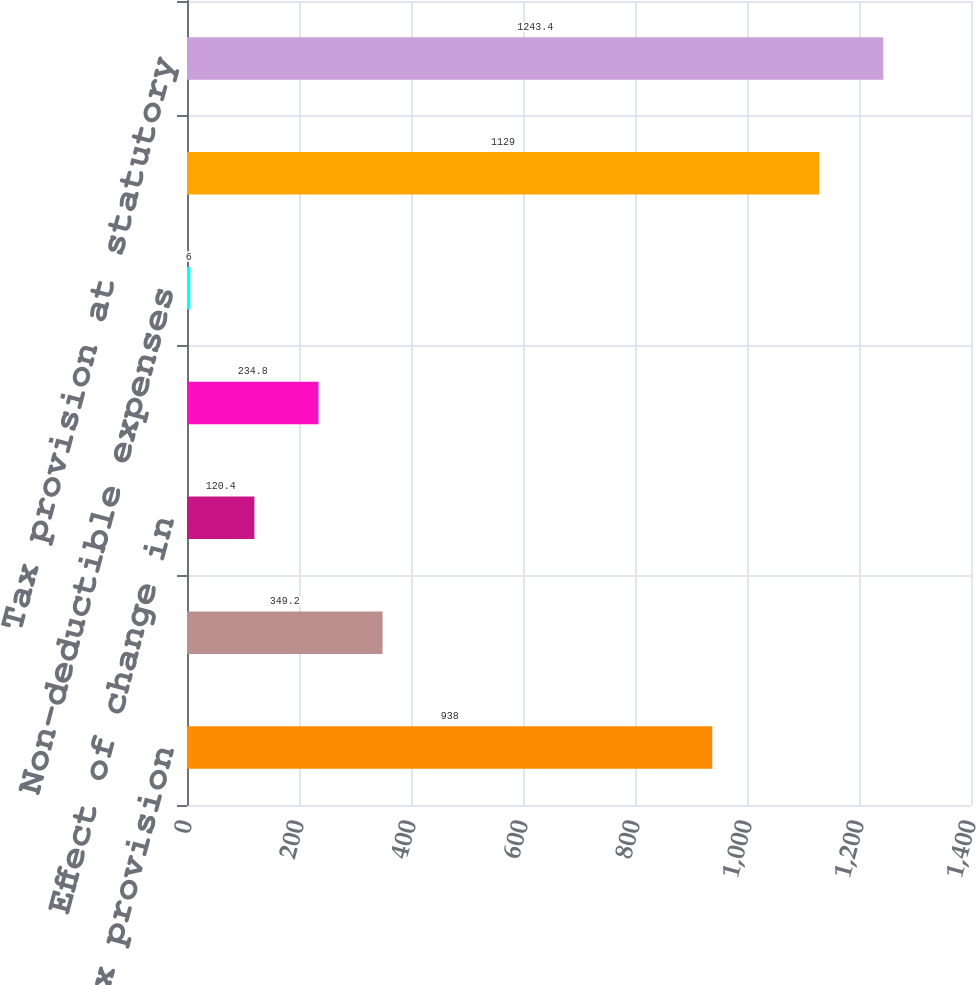Convert chart to OTSL. <chart><loc_0><loc_0><loc_500><loc_500><bar_chart><fcel>Tax provision<fcel>Non-taxable investment income<fcel>Effect of change in<fcel>Change in valuation allowance<fcel>Non-deductible expenses<fcel>Tax provision excluding these<fcel>Tax provision at statutory<nl><fcel>938<fcel>349.2<fcel>120.4<fcel>234.8<fcel>6<fcel>1129<fcel>1243.4<nl></chart> 